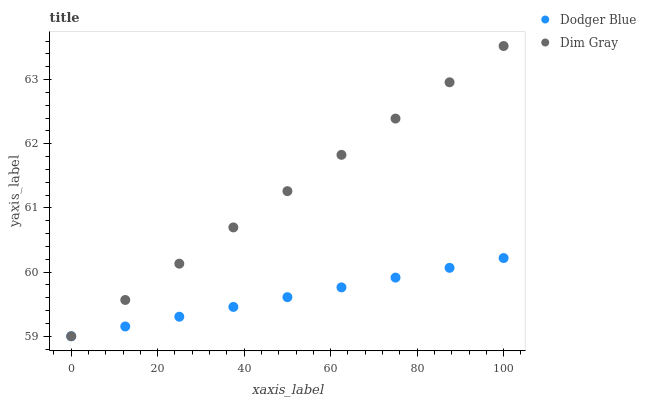Does Dodger Blue have the minimum area under the curve?
Answer yes or no. Yes. Does Dim Gray have the maximum area under the curve?
Answer yes or no. Yes. Does Dodger Blue have the maximum area under the curve?
Answer yes or no. No. Is Dodger Blue the smoothest?
Answer yes or no. Yes. Is Dim Gray the roughest?
Answer yes or no. Yes. Is Dodger Blue the roughest?
Answer yes or no. No. Does Dim Gray have the lowest value?
Answer yes or no. Yes. Does Dim Gray have the highest value?
Answer yes or no. Yes. Does Dodger Blue have the highest value?
Answer yes or no. No. Does Dim Gray intersect Dodger Blue?
Answer yes or no. Yes. Is Dim Gray less than Dodger Blue?
Answer yes or no. No. Is Dim Gray greater than Dodger Blue?
Answer yes or no. No. 